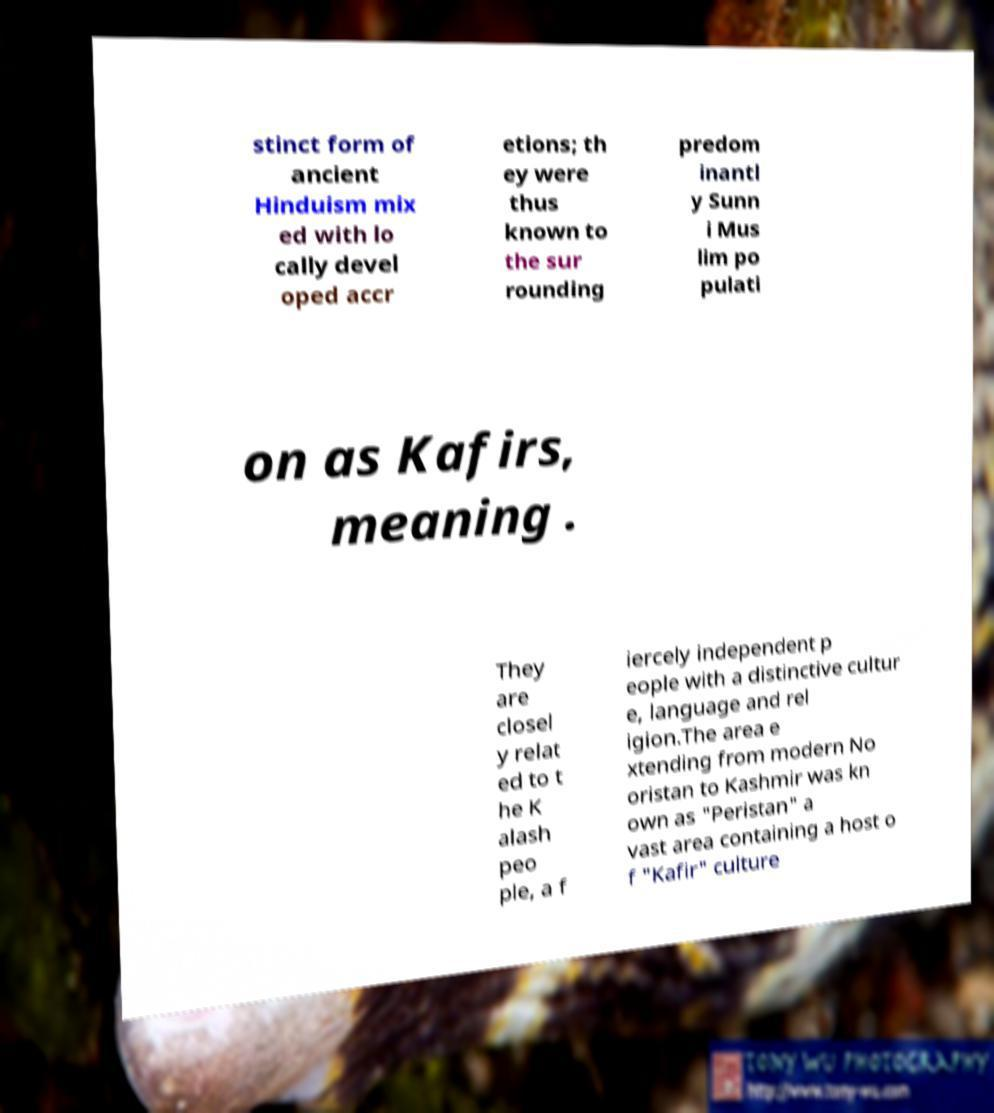Please identify and transcribe the text found in this image. stinct form of ancient Hinduism mix ed with lo cally devel oped accr etions; th ey were thus known to the sur rounding predom inantl y Sunn i Mus lim po pulati on as Kafirs, meaning . They are closel y relat ed to t he K alash peo ple, a f iercely independent p eople with a distinctive cultur e, language and rel igion.The area e xtending from modern No oristan to Kashmir was kn own as "Peristan" a vast area containing a host o f "Kafir" culture 